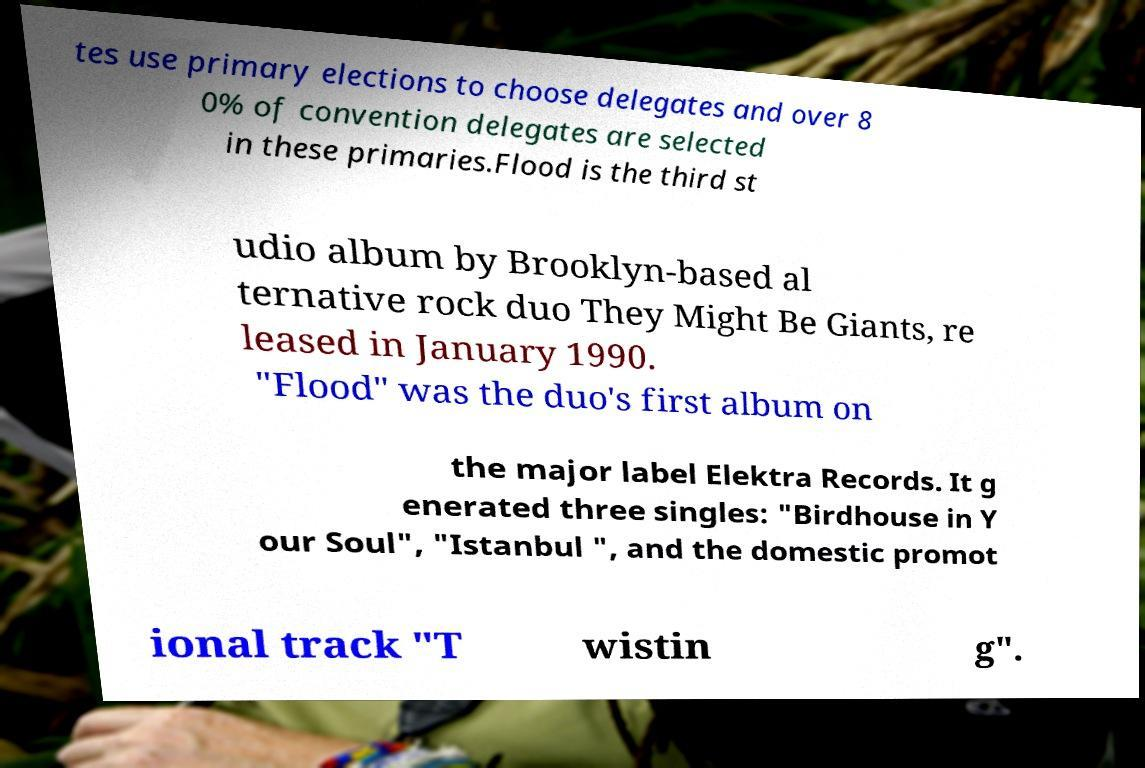There's text embedded in this image that I need extracted. Can you transcribe it verbatim? tes use primary elections to choose delegates and over 8 0% of convention delegates are selected in these primaries.Flood is the third st udio album by Brooklyn-based al ternative rock duo They Might Be Giants, re leased in January 1990. "Flood" was the duo's first album on the major label Elektra Records. It g enerated three singles: "Birdhouse in Y our Soul", "Istanbul ", and the domestic promot ional track "T wistin g". 